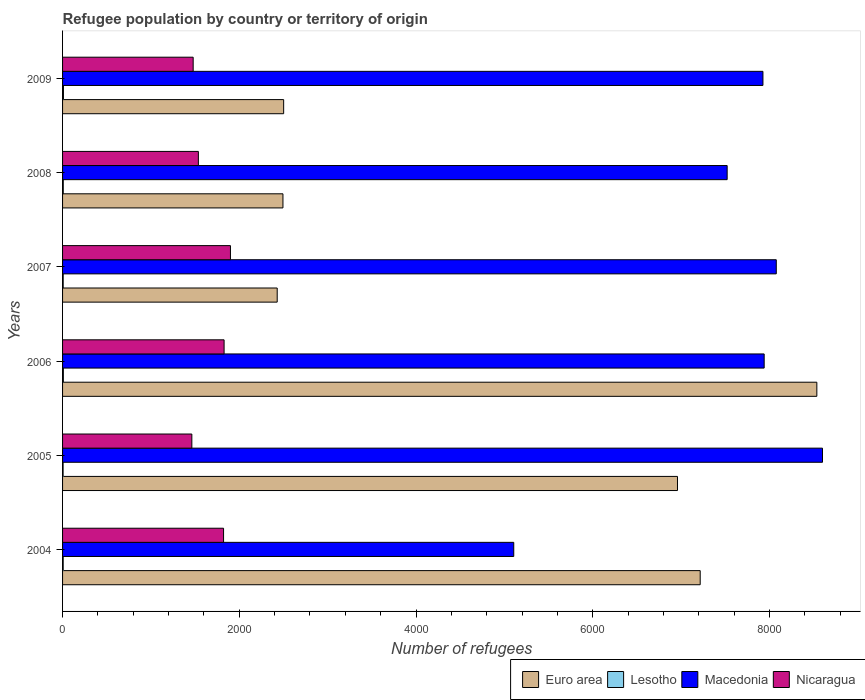How many different coloured bars are there?
Your answer should be very brief. 4. How many groups of bars are there?
Offer a very short reply. 6. Are the number of bars per tick equal to the number of legend labels?
Keep it short and to the point. Yes. How many bars are there on the 3rd tick from the top?
Offer a very short reply. 4. How many bars are there on the 5th tick from the bottom?
Provide a succinct answer. 4. What is the label of the 1st group of bars from the top?
Ensure brevity in your answer.  2009. What is the number of refugees in Macedonia in 2008?
Your response must be concise. 7521. Across all years, what is the maximum number of refugees in Lesotho?
Give a very brief answer. 10. Across all years, what is the minimum number of refugees in Euro area?
Give a very brief answer. 2429. What is the total number of refugees in Lesotho in the graph?
Give a very brief answer. 47. What is the difference between the number of refugees in Macedonia in 2006 and that in 2008?
Make the answer very short. 419. What is the difference between the number of refugees in Macedonia in 2005 and the number of refugees in Euro area in 2009?
Ensure brevity in your answer.  6098. What is the average number of refugees in Euro area per year?
Your answer should be compact. 5022.67. In the year 2004, what is the difference between the number of refugees in Lesotho and number of refugees in Nicaragua?
Give a very brief answer. -1815. In how many years, is the number of refugees in Macedonia greater than 1200 ?
Ensure brevity in your answer.  6. What is the ratio of the number of refugees in Nicaragua in 2007 to that in 2009?
Provide a succinct answer. 1.29. Is the difference between the number of refugees in Lesotho in 2004 and 2005 greater than the difference between the number of refugees in Nicaragua in 2004 and 2005?
Offer a terse response. No. What is the difference between the highest and the lowest number of refugees in Euro area?
Provide a succinct answer. 6107. Is the sum of the number of refugees in Lesotho in 2006 and 2009 greater than the maximum number of refugees in Euro area across all years?
Make the answer very short. No. What does the 3rd bar from the top in 2005 represents?
Give a very brief answer. Lesotho. What does the 3rd bar from the bottom in 2006 represents?
Make the answer very short. Macedonia. How many bars are there?
Offer a terse response. 24. Are all the bars in the graph horizontal?
Offer a terse response. Yes. What is the difference between two consecutive major ticks on the X-axis?
Offer a terse response. 2000. Where does the legend appear in the graph?
Your response must be concise. Bottom right. How many legend labels are there?
Make the answer very short. 4. What is the title of the graph?
Ensure brevity in your answer.  Refugee population by country or territory of origin. What is the label or title of the X-axis?
Keep it short and to the point. Number of refugees. What is the label or title of the Y-axis?
Your answer should be very brief. Years. What is the Number of refugees of Euro area in 2004?
Make the answer very short. 7216. What is the Number of refugees of Lesotho in 2004?
Your response must be concise. 7. What is the Number of refugees in Macedonia in 2004?
Your answer should be compact. 5106. What is the Number of refugees of Nicaragua in 2004?
Make the answer very short. 1822. What is the Number of refugees of Euro area in 2005?
Your answer should be compact. 6959. What is the Number of refugees in Lesotho in 2005?
Offer a very short reply. 6. What is the Number of refugees of Macedonia in 2005?
Your response must be concise. 8600. What is the Number of refugees of Nicaragua in 2005?
Provide a succinct answer. 1463. What is the Number of refugees of Euro area in 2006?
Your answer should be very brief. 8536. What is the Number of refugees of Lesotho in 2006?
Keep it short and to the point. 9. What is the Number of refugees of Macedonia in 2006?
Keep it short and to the point. 7940. What is the Number of refugees in Nicaragua in 2006?
Provide a succinct answer. 1828. What is the Number of refugees in Euro area in 2007?
Offer a very short reply. 2429. What is the Number of refugees of Macedonia in 2007?
Your answer should be compact. 8077. What is the Number of refugees of Nicaragua in 2007?
Your answer should be compact. 1900. What is the Number of refugees in Euro area in 2008?
Your answer should be compact. 2494. What is the Number of refugees of Macedonia in 2008?
Ensure brevity in your answer.  7521. What is the Number of refugees of Nicaragua in 2008?
Your response must be concise. 1537. What is the Number of refugees of Euro area in 2009?
Ensure brevity in your answer.  2502. What is the Number of refugees of Macedonia in 2009?
Provide a short and direct response. 7926. What is the Number of refugees in Nicaragua in 2009?
Make the answer very short. 1478. Across all years, what is the maximum Number of refugees in Euro area?
Provide a succinct answer. 8536. Across all years, what is the maximum Number of refugees of Macedonia?
Your answer should be compact. 8600. Across all years, what is the maximum Number of refugees in Nicaragua?
Ensure brevity in your answer.  1900. Across all years, what is the minimum Number of refugees of Euro area?
Your answer should be very brief. 2429. Across all years, what is the minimum Number of refugees of Lesotho?
Your answer should be very brief. 6. Across all years, what is the minimum Number of refugees in Macedonia?
Keep it short and to the point. 5106. Across all years, what is the minimum Number of refugees in Nicaragua?
Offer a very short reply. 1463. What is the total Number of refugees in Euro area in the graph?
Make the answer very short. 3.01e+04. What is the total Number of refugees of Lesotho in the graph?
Your answer should be compact. 47. What is the total Number of refugees of Macedonia in the graph?
Ensure brevity in your answer.  4.52e+04. What is the total Number of refugees in Nicaragua in the graph?
Make the answer very short. 1.00e+04. What is the difference between the Number of refugees in Euro area in 2004 and that in 2005?
Keep it short and to the point. 257. What is the difference between the Number of refugees of Lesotho in 2004 and that in 2005?
Ensure brevity in your answer.  1. What is the difference between the Number of refugees in Macedonia in 2004 and that in 2005?
Provide a succinct answer. -3494. What is the difference between the Number of refugees of Nicaragua in 2004 and that in 2005?
Offer a terse response. 359. What is the difference between the Number of refugees in Euro area in 2004 and that in 2006?
Offer a terse response. -1320. What is the difference between the Number of refugees in Macedonia in 2004 and that in 2006?
Your response must be concise. -2834. What is the difference between the Number of refugees of Nicaragua in 2004 and that in 2006?
Offer a very short reply. -6. What is the difference between the Number of refugees in Euro area in 2004 and that in 2007?
Provide a short and direct response. 4787. What is the difference between the Number of refugees of Lesotho in 2004 and that in 2007?
Your response must be concise. 0. What is the difference between the Number of refugees of Macedonia in 2004 and that in 2007?
Ensure brevity in your answer.  -2971. What is the difference between the Number of refugees in Nicaragua in 2004 and that in 2007?
Make the answer very short. -78. What is the difference between the Number of refugees in Euro area in 2004 and that in 2008?
Your answer should be compact. 4722. What is the difference between the Number of refugees in Lesotho in 2004 and that in 2008?
Make the answer very short. -1. What is the difference between the Number of refugees of Macedonia in 2004 and that in 2008?
Make the answer very short. -2415. What is the difference between the Number of refugees in Nicaragua in 2004 and that in 2008?
Ensure brevity in your answer.  285. What is the difference between the Number of refugees of Euro area in 2004 and that in 2009?
Keep it short and to the point. 4714. What is the difference between the Number of refugees in Lesotho in 2004 and that in 2009?
Offer a terse response. -3. What is the difference between the Number of refugees of Macedonia in 2004 and that in 2009?
Your response must be concise. -2820. What is the difference between the Number of refugees of Nicaragua in 2004 and that in 2009?
Your answer should be compact. 344. What is the difference between the Number of refugees in Euro area in 2005 and that in 2006?
Your answer should be compact. -1577. What is the difference between the Number of refugees of Lesotho in 2005 and that in 2006?
Provide a succinct answer. -3. What is the difference between the Number of refugees of Macedonia in 2005 and that in 2006?
Keep it short and to the point. 660. What is the difference between the Number of refugees in Nicaragua in 2005 and that in 2006?
Your response must be concise. -365. What is the difference between the Number of refugees in Euro area in 2005 and that in 2007?
Offer a very short reply. 4530. What is the difference between the Number of refugees in Macedonia in 2005 and that in 2007?
Give a very brief answer. 523. What is the difference between the Number of refugees in Nicaragua in 2005 and that in 2007?
Your answer should be compact. -437. What is the difference between the Number of refugees in Euro area in 2005 and that in 2008?
Make the answer very short. 4465. What is the difference between the Number of refugees in Macedonia in 2005 and that in 2008?
Your answer should be very brief. 1079. What is the difference between the Number of refugees of Nicaragua in 2005 and that in 2008?
Ensure brevity in your answer.  -74. What is the difference between the Number of refugees in Euro area in 2005 and that in 2009?
Your answer should be compact. 4457. What is the difference between the Number of refugees of Macedonia in 2005 and that in 2009?
Ensure brevity in your answer.  674. What is the difference between the Number of refugees of Euro area in 2006 and that in 2007?
Offer a terse response. 6107. What is the difference between the Number of refugees in Lesotho in 2006 and that in 2007?
Offer a very short reply. 2. What is the difference between the Number of refugees in Macedonia in 2006 and that in 2007?
Offer a terse response. -137. What is the difference between the Number of refugees of Nicaragua in 2006 and that in 2007?
Your answer should be compact. -72. What is the difference between the Number of refugees in Euro area in 2006 and that in 2008?
Ensure brevity in your answer.  6042. What is the difference between the Number of refugees of Macedonia in 2006 and that in 2008?
Your answer should be very brief. 419. What is the difference between the Number of refugees in Nicaragua in 2006 and that in 2008?
Your response must be concise. 291. What is the difference between the Number of refugees of Euro area in 2006 and that in 2009?
Your response must be concise. 6034. What is the difference between the Number of refugees in Lesotho in 2006 and that in 2009?
Your response must be concise. -1. What is the difference between the Number of refugees in Macedonia in 2006 and that in 2009?
Your answer should be compact. 14. What is the difference between the Number of refugees of Nicaragua in 2006 and that in 2009?
Make the answer very short. 350. What is the difference between the Number of refugees of Euro area in 2007 and that in 2008?
Ensure brevity in your answer.  -65. What is the difference between the Number of refugees in Macedonia in 2007 and that in 2008?
Provide a succinct answer. 556. What is the difference between the Number of refugees of Nicaragua in 2007 and that in 2008?
Offer a terse response. 363. What is the difference between the Number of refugees of Euro area in 2007 and that in 2009?
Your response must be concise. -73. What is the difference between the Number of refugees in Macedonia in 2007 and that in 2009?
Your answer should be very brief. 151. What is the difference between the Number of refugees of Nicaragua in 2007 and that in 2009?
Offer a very short reply. 422. What is the difference between the Number of refugees of Macedonia in 2008 and that in 2009?
Ensure brevity in your answer.  -405. What is the difference between the Number of refugees in Nicaragua in 2008 and that in 2009?
Make the answer very short. 59. What is the difference between the Number of refugees of Euro area in 2004 and the Number of refugees of Lesotho in 2005?
Provide a short and direct response. 7210. What is the difference between the Number of refugees of Euro area in 2004 and the Number of refugees of Macedonia in 2005?
Make the answer very short. -1384. What is the difference between the Number of refugees in Euro area in 2004 and the Number of refugees in Nicaragua in 2005?
Make the answer very short. 5753. What is the difference between the Number of refugees of Lesotho in 2004 and the Number of refugees of Macedonia in 2005?
Your response must be concise. -8593. What is the difference between the Number of refugees in Lesotho in 2004 and the Number of refugees in Nicaragua in 2005?
Your answer should be compact. -1456. What is the difference between the Number of refugees of Macedonia in 2004 and the Number of refugees of Nicaragua in 2005?
Keep it short and to the point. 3643. What is the difference between the Number of refugees in Euro area in 2004 and the Number of refugees in Lesotho in 2006?
Your answer should be very brief. 7207. What is the difference between the Number of refugees of Euro area in 2004 and the Number of refugees of Macedonia in 2006?
Provide a short and direct response. -724. What is the difference between the Number of refugees of Euro area in 2004 and the Number of refugees of Nicaragua in 2006?
Provide a short and direct response. 5388. What is the difference between the Number of refugees of Lesotho in 2004 and the Number of refugees of Macedonia in 2006?
Ensure brevity in your answer.  -7933. What is the difference between the Number of refugees of Lesotho in 2004 and the Number of refugees of Nicaragua in 2006?
Give a very brief answer. -1821. What is the difference between the Number of refugees in Macedonia in 2004 and the Number of refugees in Nicaragua in 2006?
Your answer should be compact. 3278. What is the difference between the Number of refugees in Euro area in 2004 and the Number of refugees in Lesotho in 2007?
Your response must be concise. 7209. What is the difference between the Number of refugees in Euro area in 2004 and the Number of refugees in Macedonia in 2007?
Keep it short and to the point. -861. What is the difference between the Number of refugees of Euro area in 2004 and the Number of refugees of Nicaragua in 2007?
Ensure brevity in your answer.  5316. What is the difference between the Number of refugees in Lesotho in 2004 and the Number of refugees in Macedonia in 2007?
Offer a terse response. -8070. What is the difference between the Number of refugees in Lesotho in 2004 and the Number of refugees in Nicaragua in 2007?
Keep it short and to the point. -1893. What is the difference between the Number of refugees of Macedonia in 2004 and the Number of refugees of Nicaragua in 2007?
Provide a short and direct response. 3206. What is the difference between the Number of refugees in Euro area in 2004 and the Number of refugees in Lesotho in 2008?
Make the answer very short. 7208. What is the difference between the Number of refugees of Euro area in 2004 and the Number of refugees of Macedonia in 2008?
Your answer should be very brief. -305. What is the difference between the Number of refugees in Euro area in 2004 and the Number of refugees in Nicaragua in 2008?
Give a very brief answer. 5679. What is the difference between the Number of refugees in Lesotho in 2004 and the Number of refugees in Macedonia in 2008?
Your answer should be very brief. -7514. What is the difference between the Number of refugees in Lesotho in 2004 and the Number of refugees in Nicaragua in 2008?
Your answer should be compact. -1530. What is the difference between the Number of refugees in Macedonia in 2004 and the Number of refugees in Nicaragua in 2008?
Ensure brevity in your answer.  3569. What is the difference between the Number of refugees in Euro area in 2004 and the Number of refugees in Lesotho in 2009?
Offer a terse response. 7206. What is the difference between the Number of refugees of Euro area in 2004 and the Number of refugees of Macedonia in 2009?
Keep it short and to the point. -710. What is the difference between the Number of refugees of Euro area in 2004 and the Number of refugees of Nicaragua in 2009?
Provide a succinct answer. 5738. What is the difference between the Number of refugees of Lesotho in 2004 and the Number of refugees of Macedonia in 2009?
Your answer should be very brief. -7919. What is the difference between the Number of refugees in Lesotho in 2004 and the Number of refugees in Nicaragua in 2009?
Give a very brief answer. -1471. What is the difference between the Number of refugees in Macedonia in 2004 and the Number of refugees in Nicaragua in 2009?
Provide a succinct answer. 3628. What is the difference between the Number of refugees of Euro area in 2005 and the Number of refugees of Lesotho in 2006?
Your answer should be compact. 6950. What is the difference between the Number of refugees of Euro area in 2005 and the Number of refugees of Macedonia in 2006?
Ensure brevity in your answer.  -981. What is the difference between the Number of refugees in Euro area in 2005 and the Number of refugees in Nicaragua in 2006?
Offer a very short reply. 5131. What is the difference between the Number of refugees of Lesotho in 2005 and the Number of refugees of Macedonia in 2006?
Keep it short and to the point. -7934. What is the difference between the Number of refugees in Lesotho in 2005 and the Number of refugees in Nicaragua in 2006?
Provide a succinct answer. -1822. What is the difference between the Number of refugees in Macedonia in 2005 and the Number of refugees in Nicaragua in 2006?
Provide a short and direct response. 6772. What is the difference between the Number of refugees in Euro area in 2005 and the Number of refugees in Lesotho in 2007?
Provide a short and direct response. 6952. What is the difference between the Number of refugees of Euro area in 2005 and the Number of refugees of Macedonia in 2007?
Give a very brief answer. -1118. What is the difference between the Number of refugees of Euro area in 2005 and the Number of refugees of Nicaragua in 2007?
Make the answer very short. 5059. What is the difference between the Number of refugees in Lesotho in 2005 and the Number of refugees in Macedonia in 2007?
Provide a succinct answer. -8071. What is the difference between the Number of refugees in Lesotho in 2005 and the Number of refugees in Nicaragua in 2007?
Your answer should be very brief. -1894. What is the difference between the Number of refugees of Macedonia in 2005 and the Number of refugees of Nicaragua in 2007?
Make the answer very short. 6700. What is the difference between the Number of refugees of Euro area in 2005 and the Number of refugees of Lesotho in 2008?
Provide a short and direct response. 6951. What is the difference between the Number of refugees in Euro area in 2005 and the Number of refugees in Macedonia in 2008?
Provide a succinct answer. -562. What is the difference between the Number of refugees of Euro area in 2005 and the Number of refugees of Nicaragua in 2008?
Provide a short and direct response. 5422. What is the difference between the Number of refugees of Lesotho in 2005 and the Number of refugees of Macedonia in 2008?
Ensure brevity in your answer.  -7515. What is the difference between the Number of refugees in Lesotho in 2005 and the Number of refugees in Nicaragua in 2008?
Your response must be concise. -1531. What is the difference between the Number of refugees in Macedonia in 2005 and the Number of refugees in Nicaragua in 2008?
Keep it short and to the point. 7063. What is the difference between the Number of refugees of Euro area in 2005 and the Number of refugees of Lesotho in 2009?
Your response must be concise. 6949. What is the difference between the Number of refugees in Euro area in 2005 and the Number of refugees in Macedonia in 2009?
Make the answer very short. -967. What is the difference between the Number of refugees of Euro area in 2005 and the Number of refugees of Nicaragua in 2009?
Make the answer very short. 5481. What is the difference between the Number of refugees in Lesotho in 2005 and the Number of refugees in Macedonia in 2009?
Offer a terse response. -7920. What is the difference between the Number of refugees in Lesotho in 2005 and the Number of refugees in Nicaragua in 2009?
Give a very brief answer. -1472. What is the difference between the Number of refugees of Macedonia in 2005 and the Number of refugees of Nicaragua in 2009?
Give a very brief answer. 7122. What is the difference between the Number of refugees in Euro area in 2006 and the Number of refugees in Lesotho in 2007?
Give a very brief answer. 8529. What is the difference between the Number of refugees in Euro area in 2006 and the Number of refugees in Macedonia in 2007?
Keep it short and to the point. 459. What is the difference between the Number of refugees of Euro area in 2006 and the Number of refugees of Nicaragua in 2007?
Your answer should be compact. 6636. What is the difference between the Number of refugees in Lesotho in 2006 and the Number of refugees in Macedonia in 2007?
Ensure brevity in your answer.  -8068. What is the difference between the Number of refugees in Lesotho in 2006 and the Number of refugees in Nicaragua in 2007?
Offer a very short reply. -1891. What is the difference between the Number of refugees of Macedonia in 2006 and the Number of refugees of Nicaragua in 2007?
Your response must be concise. 6040. What is the difference between the Number of refugees in Euro area in 2006 and the Number of refugees in Lesotho in 2008?
Your answer should be compact. 8528. What is the difference between the Number of refugees in Euro area in 2006 and the Number of refugees in Macedonia in 2008?
Give a very brief answer. 1015. What is the difference between the Number of refugees of Euro area in 2006 and the Number of refugees of Nicaragua in 2008?
Keep it short and to the point. 6999. What is the difference between the Number of refugees of Lesotho in 2006 and the Number of refugees of Macedonia in 2008?
Give a very brief answer. -7512. What is the difference between the Number of refugees of Lesotho in 2006 and the Number of refugees of Nicaragua in 2008?
Provide a succinct answer. -1528. What is the difference between the Number of refugees of Macedonia in 2006 and the Number of refugees of Nicaragua in 2008?
Keep it short and to the point. 6403. What is the difference between the Number of refugees in Euro area in 2006 and the Number of refugees in Lesotho in 2009?
Give a very brief answer. 8526. What is the difference between the Number of refugees in Euro area in 2006 and the Number of refugees in Macedonia in 2009?
Make the answer very short. 610. What is the difference between the Number of refugees in Euro area in 2006 and the Number of refugees in Nicaragua in 2009?
Your answer should be compact. 7058. What is the difference between the Number of refugees of Lesotho in 2006 and the Number of refugees of Macedonia in 2009?
Give a very brief answer. -7917. What is the difference between the Number of refugees in Lesotho in 2006 and the Number of refugees in Nicaragua in 2009?
Ensure brevity in your answer.  -1469. What is the difference between the Number of refugees of Macedonia in 2006 and the Number of refugees of Nicaragua in 2009?
Your response must be concise. 6462. What is the difference between the Number of refugees of Euro area in 2007 and the Number of refugees of Lesotho in 2008?
Offer a terse response. 2421. What is the difference between the Number of refugees of Euro area in 2007 and the Number of refugees of Macedonia in 2008?
Offer a very short reply. -5092. What is the difference between the Number of refugees in Euro area in 2007 and the Number of refugees in Nicaragua in 2008?
Your answer should be compact. 892. What is the difference between the Number of refugees in Lesotho in 2007 and the Number of refugees in Macedonia in 2008?
Offer a terse response. -7514. What is the difference between the Number of refugees in Lesotho in 2007 and the Number of refugees in Nicaragua in 2008?
Offer a very short reply. -1530. What is the difference between the Number of refugees in Macedonia in 2007 and the Number of refugees in Nicaragua in 2008?
Give a very brief answer. 6540. What is the difference between the Number of refugees of Euro area in 2007 and the Number of refugees of Lesotho in 2009?
Make the answer very short. 2419. What is the difference between the Number of refugees in Euro area in 2007 and the Number of refugees in Macedonia in 2009?
Offer a terse response. -5497. What is the difference between the Number of refugees in Euro area in 2007 and the Number of refugees in Nicaragua in 2009?
Keep it short and to the point. 951. What is the difference between the Number of refugees in Lesotho in 2007 and the Number of refugees in Macedonia in 2009?
Make the answer very short. -7919. What is the difference between the Number of refugees of Lesotho in 2007 and the Number of refugees of Nicaragua in 2009?
Keep it short and to the point. -1471. What is the difference between the Number of refugees of Macedonia in 2007 and the Number of refugees of Nicaragua in 2009?
Your response must be concise. 6599. What is the difference between the Number of refugees in Euro area in 2008 and the Number of refugees in Lesotho in 2009?
Your answer should be very brief. 2484. What is the difference between the Number of refugees of Euro area in 2008 and the Number of refugees of Macedonia in 2009?
Offer a terse response. -5432. What is the difference between the Number of refugees of Euro area in 2008 and the Number of refugees of Nicaragua in 2009?
Your answer should be very brief. 1016. What is the difference between the Number of refugees of Lesotho in 2008 and the Number of refugees of Macedonia in 2009?
Your answer should be very brief. -7918. What is the difference between the Number of refugees of Lesotho in 2008 and the Number of refugees of Nicaragua in 2009?
Provide a succinct answer. -1470. What is the difference between the Number of refugees of Macedonia in 2008 and the Number of refugees of Nicaragua in 2009?
Your response must be concise. 6043. What is the average Number of refugees in Euro area per year?
Ensure brevity in your answer.  5022.67. What is the average Number of refugees in Lesotho per year?
Make the answer very short. 7.83. What is the average Number of refugees of Macedonia per year?
Provide a short and direct response. 7528.33. What is the average Number of refugees in Nicaragua per year?
Your answer should be very brief. 1671.33. In the year 2004, what is the difference between the Number of refugees of Euro area and Number of refugees of Lesotho?
Give a very brief answer. 7209. In the year 2004, what is the difference between the Number of refugees in Euro area and Number of refugees in Macedonia?
Keep it short and to the point. 2110. In the year 2004, what is the difference between the Number of refugees in Euro area and Number of refugees in Nicaragua?
Offer a very short reply. 5394. In the year 2004, what is the difference between the Number of refugees in Lesotho and Number of refugees in Macedonia?
Give a very brief answer. -5099. In the year 2004, what is the difference between the Number of refugees of Lesotho and Number of refugees of Nicaragua?
Provide a short and direct response. -1815. In the year 2004, what is the difference between the Number of refugees of Macedonia and Number of refugees of Nicaragua?
Make the answer very short. 3284. In the year 2005, what is the difference between the Number of refugees in Euro area and Number of refugees in Lesotho?
Provide a succinct answer. 6953. In the year 2005, what is the difference between the Number of refugees in Euro area and Number of refugees in Macedonia?
Offer a terse response. -1641. In the year 2005, what is the difference between the Number of refugees in Euro area and Number of refugees in Nicaragua?
Provide a short and direct response. 5496. In the year 2005, what is the difference between the Number of refugees in Lesotho and Number of refugees in Macedonia?
Your answer should be very brief. -8594. In the year 2005, what is the difference between the Number of refugees of Lesotho and Number of refugees of Nicaragua?
Provide a short and direct response. -1457. In the year 2005, what is the difference between the Number of refugees in Macedonia and Number of refugees in Nicaragua?
Your response must be concise. 7137. In the year 2006, what is the difference between the Number of refugees of Euro area and Number of refugees of Lesotho?
Provide a short and direct response. 8527. In the year 2006, what is the difference between the Number of refugees in Euro area and Number of refugees in Macedonia?
Your answer should be very brief. 596. In the year 2006, what is the difference between the Number of refugees of Euro area and Number of refugees of Nicaragua?
Your response must be concise. 6708. In the year 2006, what is the difference between the Number of refugees in Lesotho and Number of refugees in Macedonia?
Give a very brief answer. -7931. In the year 2006, what is the difference between the Number of refugees of Lesotho and Number of refugees of Nicaragua?
Provide a short and direct response. -1819. In the year 2006, what is the difference between the Number of refugees in Macedonia and Number of refugees in Nicaragua?
Offer a terse response. 6112. In the year 2007, what is the difference between the Number of refugees in Euro area and Number of refugees in Lesotho?
Give a very brief answer. 2422. In the year 2007, what is the difference between the Number of refugees in Euro area and Number of refugees in Macedonia?
Provide a succinct answer. -5648. In the year 2007, what is the difference between the Number of refugees of Euro area and Number of refugees of Nicaragua?
Provide a short and direct response. 529. In the year 2007, what is the difference between the Number of refugees of Lesotho and Number of refugees of Macedonia?
Offer a terse response. -8070. In the year 2007, what is the difference between the Number of refugees of Lesotho and Number of refugees of Nicaragua?
Offer a very short reply. -1893. In the year 2007, what is the difference between the Number of refugees in Macedonia and Number of refugees in Nicaragua?
Keep it short and to the point. 6177. In the year 2008, what is the difference between the Number of refugees in Euro area and Number of refugees in Lesotho?
Ensure brevity in your answer.  2486. In the year 2008, what is the difference between the Number of refugees in Euro area and Number of refugees in Macedonia?
Make the answer very short. -5027. In the year 2008, what is the difference between the Number of refugees of Euro area and Number of refugees of Nicaragua?
Give a very brief answer. 957. In the year 2008, what is the difference between the Number of refugees in Lesotho and Number of refugees in Macedonia?
Provide a short and direct response. -7513. In the year 2008, what is the difference between the Number of refugees in Lesotho and Number of refugees in Nicaragua?
Provide a short and direct response. -1529. In the year 2008, what is the difference between the Number of refugees in Macedonia and Number of refugees in Nicaragua?
Provide a succinct answer. 5984. In the year 2009, what is the difference between the Number of refugees of Euro area and Number of refugees of Lesotho?
Give a very brief answer. 2492. In the year 2009, what is the difference between the Number of refugees of Euro area and Number of refugees of Macedonia?
Offer a terse response. -5424. In the year 2009, what is the difference between the Number of refugees of Euro area and Number of refugees of Nicaragua?
Offer a very short reply. 1024. In the year 2009, what is the difference between the Number of refugees of Lesotho and Number of refugees of Macedonia?
Provide a short and direct response. -7916. In the year 2009, what is the difference between the Number of refugees of Lesotho and Number of refugees of Nicaragua?
Provide a succinct answer. -1468. In the year 2009, what is the difference between the Number of refugees of Macedonia and Number of refugees of Nicaragua?
Give a very brief answer. 6448. What is the ratio of the Number of refugees of Euro area in 2004 to that in 2005?
Keep it short and to the point. 1.04. What is the ratio of the Number of refugees of Lesotho in 2004 to that in 2005?
Your response must be concise. 1.17. What is the ratio of the Number of refugees of Macedonia in 2004 to that in 2005?
Give a very brief answer. 0.59. What is the ratio of the Number of refugees in Nicaragua in 2004 to that in 2005?
Provide a succinct answer. 1.25. What is the ratio of the Number of refugees in Euro area in 2004 to that in 2006?
Provide a succinct answer. 0.85. What is the ratio of the Number of refugees of Macedonia in 2004 to that in 2006?
Offer a terse response. 0.64. What is the ratio of the Number of refugees in Euro area in 2004 to that in 2007?
Make the answer very short. 2.97. What is the ratio of the Number of refugees of Macedonia in 2004 to that in 2007?
Your answer should be very brief. 0.63. What is the ratio of the Number of refugees of Nicaragua in 2004 to that in 2007?
Ensure brevity in your answer.  0.96. What is the ratio of the Number of refugees of Euro area in 2004 to that in 2008?
Your answer should be very brief. 2.89. What is the ratio of the Number of refugees of Lesotho in 2004 to that in 2008?
Provide a short and direct response. 0.88. What is the ratio of the Number of refugees of Macedonia in 2004 to that in 2008?
Ensure brevity in your answer.  0.68. What is the ratio of the Number of refugees of Nicaragua in 2004 to that in 2008?
Ensure brevity in your answer.  1.19. What is the ratio of the Number of refugees of Euro area in 2004 to that in 2009?
Keep it short and to the point. 2.88. What is the ratio of the Number of refugees of Lesotho in 2004 to that in 2009?
Give a very brief answer. 0.7. What is the ratio of the Number of refugees of Macedonia in 2004 to that in 2009?
Make the answer very short. 0.64. What is the ratio of the Number of refugees of Nicaragua in 2004 to that in 2009?
Your answer should be compact. 1.23. What is the ratio of the Number of refugees in Euro area in 2005 to that in 2006?
Keep it short and to the point. 0.82. What is the ratio of the Number of refugees in Macedonia in 2005 to that in 2006?
Keep it short and to the point. 1.08. What is the ratio of the Number of refugees in Nicaragua in 2005 to that in 2006?
Your response must be concise. 0.8. What is the ratio of the Number of refugees of Euro area in 2005 to that in 2007?
Offer a very short reply. 2.87. What is the ratio of the Number of refugees of Lesotho in 2005 to that in 2007?
Keep it short and to the point. 0.86. What is the ratio of the Number of refugees of Macedonia in 2005 to that in 2007?
Give a very brief answer. 1.06. What is the ratio of the Number of refugees of Nicaragua in 2005 to that in 2007?
Ensure brevity in your answer.  0.77. What is the ratio of the Number of refugees of Euro area in 2005 to that in 2008?
Offer a terse response. 2.79. What is the ratio of the Number of refugees of Macedonia in 2005 to that in 2008?
Make the answer very short. 1.14. What is the ratio of the Number of refugees in Nicaragua in 2005 to that in 2008?
Give a very brief answer. 0.95. What is the ratio of the Number of refugees in Euro area in 2005 to that in 2009?
Offer a very short reply. 2.78. What is the ratio of the Number of refugees of Lesotho in 2005 to that in 2009?
Make the answer very short. 0.6. What is the ratio of the Number of refugees of Macedonia in 2005 to that in 2009?
Your answer should be very brief. 1.08. What is the ratio of the Number of refugees of Euro area in 2006 to that in 2007?
Offer a terse response. 3.51. What is the ratio of the Number of refugees in Lesotho in 2006 to that in 2007?
Your answer should be compact. 1.29. What is the ratio of the Number of refugees in Nicaragua in 2006 to that in 2007?
Provide a succinct answer. 0.96. What is the ratio of the Number of refugees in Euro area in 2006 to that in 2008?
Provide a succinct answer. 3.42. What is the ratio of the Number of refugees of Macedonia in 2006 to that in 2008?
Provide a short and direct response. 1.06. What is the ratio of the Number of refugees in Nicaragua in 2006 to that in 2008?
Provide a short and direct response. 1.19. What is the ratio of the Number of refugees of Euro area in 2006 to that in 2009?
Your response must be concise. 3.41. What is the ratio of the Number of refugees in Lesotho in 2006 to that in 2009?
Provide a succinct answer. 0.9. What is the ratio of the Number of refugees in Nicaragua in 2006 to that in 2009?
Your answer should be compact. 1.24. What is the ratio of the Number of refugees of Euro area in 2007 to that in 2008?
Ensure brevity in your answer.  0.97. What is the ratio of the Number of refugees of Macedonia in 2007 to that in 2008?
Offer a very short reply. 1.07. What is the ratio of the Number of refugees of Nicaragua in 2007 to that in 2008?
Your answer should be compact. 1.24. What is the ratio of the Number of refugees of Euro area in 2007 to that in 2009?
Offer a terse response. 0.97. What is the ratio of the Number of refugees of Lesotho in 2007 to that in 2009?
Your answer should be very brief. 0.7. What is the ratio of the Number of refugees of Macedonia in 2007 to that in 2009?
Your response must be concise. 1.02. What is the ratio of the Number of refugees in Nicaragua in 2007 to that in 2009?
Provide a short and direct response. 1.29. What is the ratio of the Number of refugees in Macedonia in 2008 to that in 2009?
Offer a very short reply. 0.95. What is the ratio of the Number of refugees in Nicaragua in 2008 to that in 2009?
Make the answer very short. 1.04. What is the difference between the highest and the second highest Number of refugees of Euro area?
Provide a succinct answer. 1320. What is the difference between the highest and the second highest Number of refugees in Macedonia?
Ensure brevity in your answer.  523. What is the difference between the highest and the lowest Number of refugees in Euro area?
Keep it short and to the point. 6107. What is the difference between the highest and the lowest Number of refugees of Lesotho?
Your answer should be compact. 4. What is the difference between the highest and the lowest Number of refugees in Macedonia?
Your answer should be compact. 3494. What is the difference between the highest and the lowest Number of refugees of Nicaragua?
Offer a terse response. 437. 